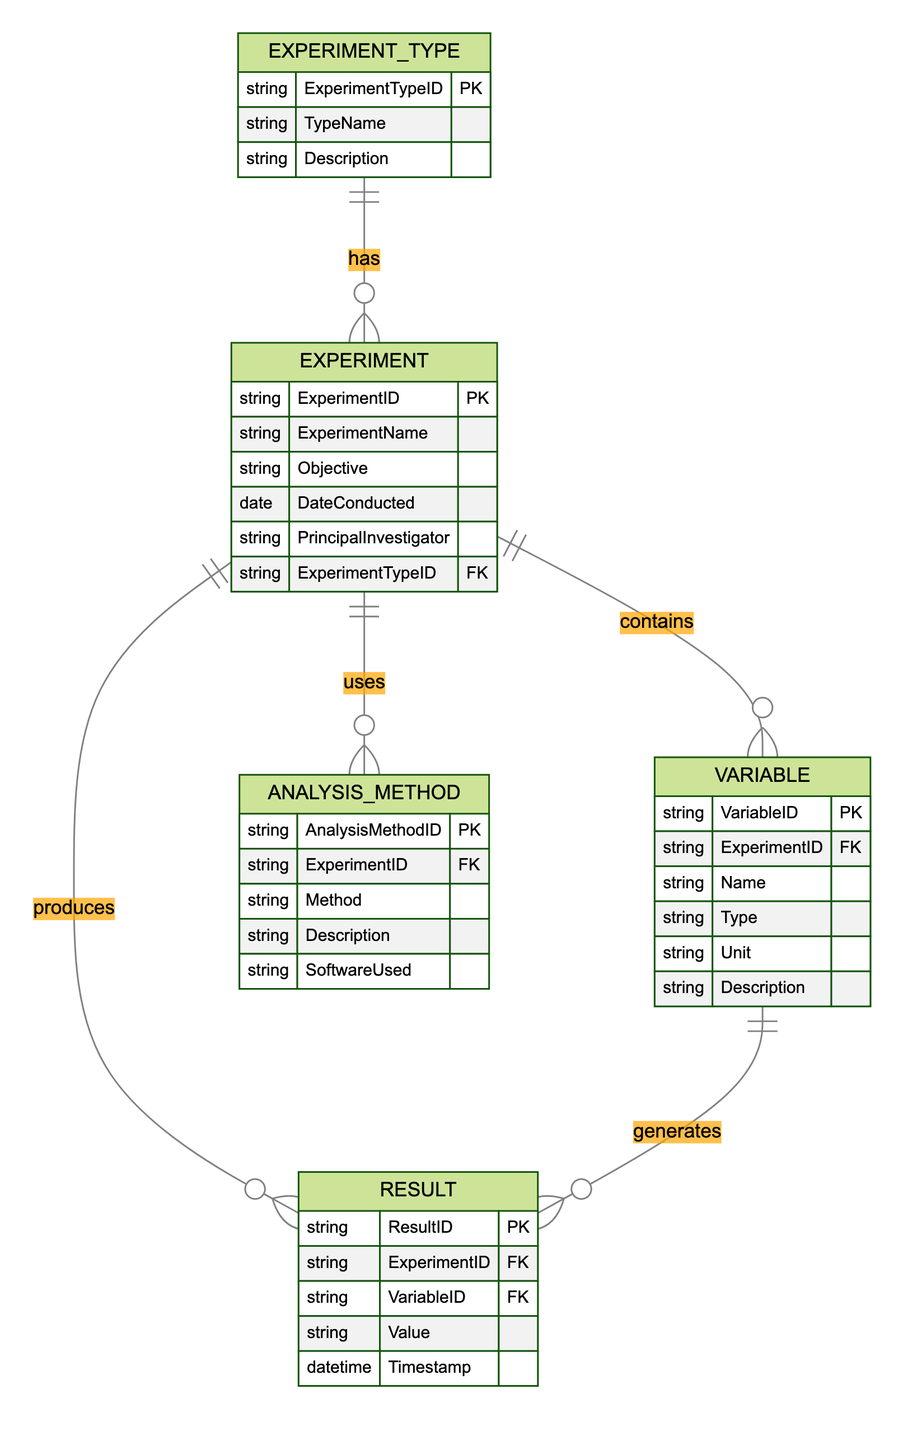What is the primary key of the Experiment entity? The primary key of the Experiment entity is ExperimentID, which uniquely identifies each experiment in the diagram.
Answer: ExperimentID How many attributes does the Result entity have? Counting the attributes listed in the Result entity, there are five: ResultID, ExperimentID, VariableID, Value, and Timestamp.
Answer: 5 What type of relationship exists between Experiment and Variable? The relationship from Experiment to Variable is One-to-Many, meaning each experiment can contain multiple variables.
Answer: One-to-Many Which entity's primary key is used as a foreign key in the Variable entity? The primary key of the Experiment entity (ExperimentID) is used as a foreign key in the Variable entity to establish a relationship between them.
Answer: Experiment What does the AnalysisMethod entity include as an attribute? The AnalysisMethod entity includes attributes such as AnalysisMethodID, ExperimentID, Method, Description, and SoftwareUsed.
Answer: Method How many different types of entities are represented in the diagram? There are five different types of entities represented: Experiment, ExperimentType, Variable, Result, and AnalysisMethod.
Answer: 5 What is the nature of the relationship between Variable and Result? The relationship between Variable and Result is also One-to-Many, indicating that each variable can correspond to multiple results.
Answer: One-to-Many What does ExperimentType represent in the context of the Experiment entity? ExperimentType represents different types of experiments and provides a description, which relates back to specific experiments through a One-to-Many relationship.
Answer: Experiment types Which attribute of AnalysisMethod indicates the software used for analysis? The attribute SoftwareUsed within AnalysisMethod specifies the software that was used for the analysis of the experiment data.
Answer: SoftwareUsed 